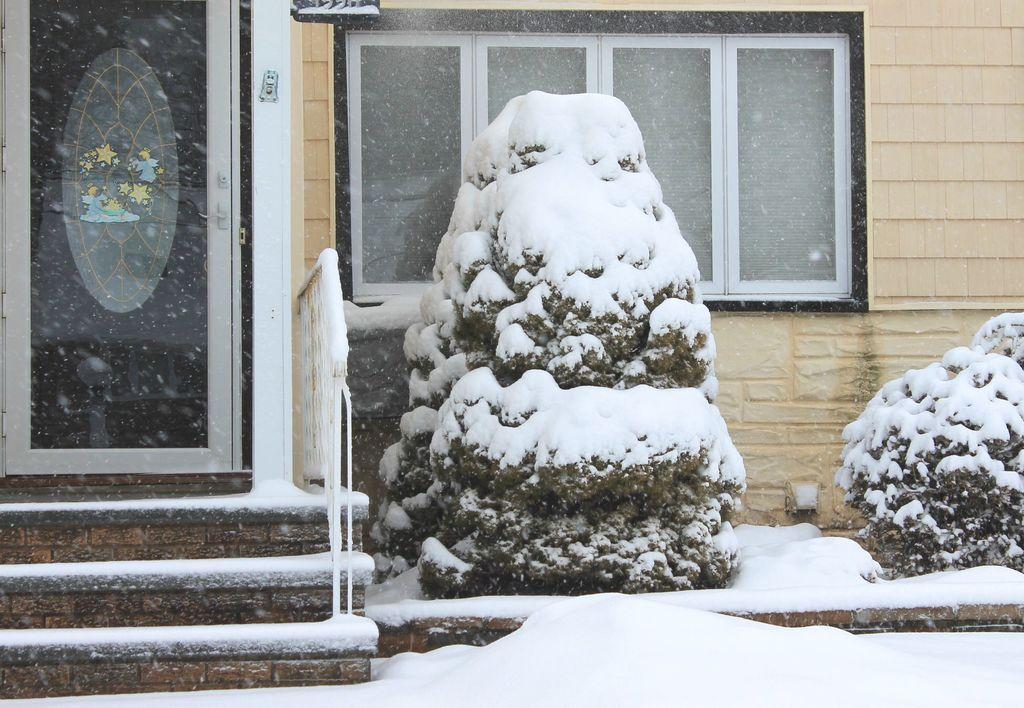In one or two sentences, can you explain what this image depicts? At the left side of the image there is a glass door. In front of the door there are steps covered with snow and also there is a railing. At the right side of the image there are plants covered with snow. Behind the plants there is a wall and also there is a window. 